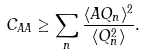Convert formula to latex. <formula><loc_0><loc_0><loc_500><loc_500>C _ { A A } \geq \sum _ { n } \frac { \langle A Q _ { n } \rangle ^ { 2 } } { \langle Q _ { n } ^ { 2 } \rangle } .</formula> 